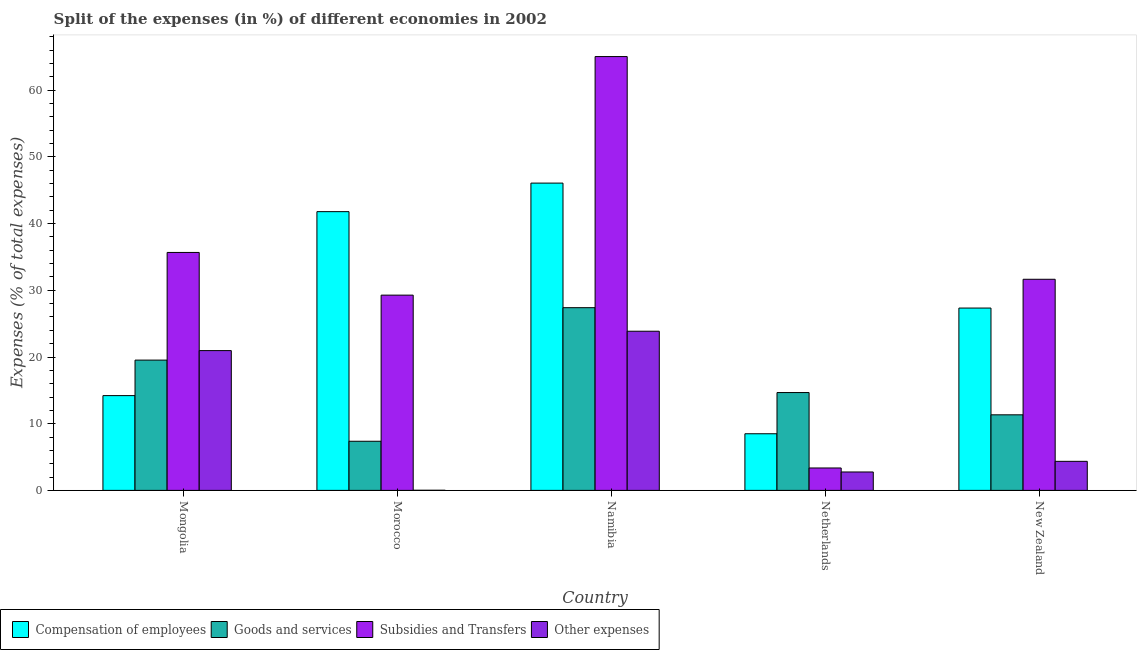How many different coloured bars are there?
Provide a succinct answer. 4. Are the number of bars per tick equal to the number of legend labels?
Keep it short and to the point. Yes. How many bars are there on the 4th tick from the right?
Provide a short and direct response. 4. What is the label of the 3rd group of bars from the left?
Provide a succinct answer. Namibia. What is the percentage of amount spent on other expenses in New Zealand?
Give a very brief answer. 4.36. Across all countries, what is the maximum percentage of amount spent on subsidies?
Offer a very short reply. 65.05. Across all countries, what is the minimum percentage of amount spent on goods and services?
Offer a terse response. 7.37. In which country was the percentage of amount spent on compensation of employees maximum?
Give a very brief answer. Namibia. In which country was the percentage of amount spent on goods and services minimum?
Your response must be concise. Morocco. What is the total percentage of amount spent on subsidies in the graph?
Your response must be concise. 165.03. What is the difference between the percentage of amount spent on subsidies in Namibia and that in Netherlands?
Your answer should be compact. 61.69. What is the difference between the percentage of amount spent on compensation of employees in Netherlands and the percentage of amount spent on subsidies in Mongolia?
Keep it short and to the point. -27.19. What is the average percentage of amount spent on other expenses per country?
Keep it short and to the point. 10.39. What is the difference between the percentage of amount spent on other expenses and percentage of amount spent on subsidies in New Zealand?
Your response must be concise. -27.3. In how many countries, is the percentage of amount spent on subsidies greater than 34 %?
Make the answer very short. 2. What is the ratio of the percentage of amount spent on subsidies in Mongolia to that in Netherlands?
Give a very brief answer. 10.62. Is the percentage of amount spent on goods and services in Mongolia less than that in Namibia?
Your response must be concise. Yes. Is the difference between the percentage of amount spent on subsidies in Mongolia and Netherlands greater than the difference between the percentage of amount spent on compensation of employees in Mongolia and Netherlands?
Keep it short and to the point. Yes. What is the difference between the highest and the second highest percentage of amount spent on other expenses?
Your response must be concise. 2.9. What is the difference between the highest and the lowest percentage of amount spent on subsidies?
Provide a short and direct response. 61.69. Is the sum of the percentage of amount spent on goods and services in Netherlands and New Zealand greater than the maximum percentage of amount spent on other expenses across all countries?
Your response must be concise. Yes. Is it the case that in every country, the sum of the percentage of amount spent on subsidies and percentage of amount spent on other expenses is greater than the sum of percentage of amount spent on goods and services and percentage of amount spent on compensation of employees?
Give a very brief answer. No. What does the 1st bar from the left in Namibia represents?
Your answer should be compact. Compensation of employees. What does the 3rd bar from the right in Mongolia represents?
Ensure brevity in your answer.  Goods and services. How many bars are there?
Offer a very short reply. 20. How many countries are there in the graph?
Offer a very short reply. 5. Are the values on the major ticks of Y-axis written in scientific E-notation?
Offer a terse response. No. Does the graph contain any zero values?
Provide a short and direct response. No. Does the graph contain grids?
Provide a succinct answer. No. Where does the legend appear in the graph?
Your answer should be very brief. Bottom left. How many legend labels are there?
Ensure brevity in your answer.  4. What is the title of the graph?
Offer a very short reply. Split of the expenses (in %) of different economies in 2002. What is the label or title of the Y-axis?
Provide a succinct answer. Expenses (% of total expenses). What is the Expenses (% of total expenses) in Compensation of employees in Mongolia?
Your response must be concise. 14.21. What is the Expenses (% of total expenses) of Goods and services in Mongolia?
Your answer should be very brief. 19.54. What is the Expenses (% of total expenses) in Subsidies and Transfers in Mongolia?
Offer a terse response. 35.68. What is the Expenses (% of total expenses) of Other expenses in Mongolia?
Give a very brief answer. 20.96. What is the Expenses (% of total expenses) in Compensation of employees in Morocco?
Ensure brevity in your answer.  41.8. What is the Expenses (% of total expenses) in Goods and services in Morocco?
Ensure brevity in your answer.  7.37. What is the Expenses (% of total expenses) in Subsidies and Transfers in Morocco?
Keep it short and to the point. 29.28. What is the Expenses (% of total expenses) of Other expenses in Morocco?
Give a very brief answer. 0.02. What is the Expenses (% of total expenses) in Compensation of employees in Namibia?
Your answer should be compact. 46.08. What is the Expenses (% of total expenses) of Goods and services in Namibia?
Provide a short and direct response. 27.4. What is the Expenses (% of total expenses) in Subsidies and Transfers in Namibia?
Your answer should be very brief. 65.05. What is the Expenses (% of total expenses) of Other expenses in Namibia?
Your response must be concise. 23.87. What is the Expenses (% of total expenses) of Compensation of employees in Netherlands?
Ensure brevity in your answer.  8.49. What is the Expenses (% of total expenses) of Goods and services in Netherlands?
Ensure brevity in your answer.  14.67. What is the Expenses (% of total expenses) in Subsidies and Transfers in Netherlands?
Keep it short and to the point. 3.36. What is the Expenses (% of total expenses) in Other expenses in Netherlands?
Provide a short and direct response. 2.76. What is the Expenses (% of total expenses) in Compensation of employees in New Zealand?
Your answer should be compact. 27.34. What is the Expenses (% of total expenses) in Goods and services in New Zealand?
Make the answer very short. 11.33. What is the Expenses (% of total expenses) in Subsidies and Transfers in New Zealand?
Your answer should be compact. 31.66. What is the Expenses (% of total expenses) in Other expenses in New Zealand?
Keep it short and to the point. 4.36. Across all countries, what is the maximum Expenses (% of total expenses) in Compensation of employees?
Ensure brevity in your answer.  46.08. Across all countries, what is the maximum Expenses (% of total expenses) in Goods and services?
Provide a short and direct response. 27.4. Across all countries, what is the maximum Expenses (% of total expenses) in Subsidies and Transfers?
Provide a short and direct response. 65.05. Across all countries, what is the maximum Expenses (% of total expenses) of Other expenses?
Offer a very short reply. 23.87. Across all countries, what is the minimum Expenses (% of total expenses) in Compensation of employees?
Offer a very short reply. 8.49. Across all countries, what is the minimum Expenses (% of total expenses) of Goods and services?
Keep it short and to the point. 7.37. Across all countries, what is the minimum Expenses (% of total expenses) of Subsidies and Transfers?
Your answer should be compact. 3.36. Across all countries, what is the minimum Expenses (% of total expenses) of Other expenses?
Your answer should be compact. 0.02. What is the total Expenses (% of total expenses) in Compensation of employees in the graph?
Your answer should be compact. 137.92. What is the total Expenses (% of total expenses) of Goods and services in the graph?
Ensure brevity in your answer.  80.3. What is the total Expenses (% of total expenses) of Subsidies and Transfers in the graph?
Offer a terse response. 165.03. What is the total Expenses (% of total expenses) of Other expenses in the graph?
Your answer should be compact. 51.96. What is the difference between the Expenses (% of total expenses) of Compensation of employees in Mongolia and that in Morocco?
Provide a succinct answer. -27.59. What is the difference between the Expenses (% of total expenses) in Goods and services in Mongolia and that in Morocco?
Your response must be concise. 12.17. What is the difference between the Expenses (% of total expenses) of Subsidies and Transfers in Mongolia and that in Morocco?
Make the answer very short. 6.4. What is the difference between the Expenses (% of total expenses) of Other expenses in Mongolia and that in Morocco?
Keep it short and to the point. 20.95. What is the difference between the Expenses (% of total expenses) in Compensation of employees in Mongolia and that in Namibia?
Give a very brief answer. -31.86. What is the difference between the Expenses (% of total expenses) in Goods and services in Mongolia and that in Namibia?
Offer a very short reply. -7.86. What is the difference between the Expenses (% of total expenses) in Subsidies and Transfers in Mongolia and that in Namibia?
Offer a terse response. -29.37. What is the difference between the Expenses (% of total expenses) of Other expenses in Mongolia and that in Namibia?
Your answer should be compact. -2.9. What is the difference between the Expenses (% of total expenses) in Compensation of employees in Mongolia and that in Netherlands?
Your answer should be very brief. 5.72. What is the difference between the Expenses (% of total expenses) in Goods and services in Mongolia and that in Netherlands?
Ensure brevity in your answer.  4.87. What is the difference between the Expenses (% of total expenses) in Subsidies and Transfers in Mongolia and that in Netherlands?
Offer a terse response. 32.32. What is the difference between the Expenses (% of total expenses) in Other expenses in Mongolia and that in Netherlands?
Offer a very short reply. 18.2. What is the difference between the Expenses (% of total expenses) of Compensation of employees in Mongolia and that in New Zealand?
Provide a short and direct response. -13.13. What is the difference between the Expenses (% of total expenses) in Goods and services in Mongolia and that in New Zealand?
Your answer should be very brief. 8.2. What is the difference between the Expenses (% of total expenses) of Subsidies and Transfers in Mongolia and that in New Zealand?
Provide a short and direct response. 4.02. What is the difference between the Expenses (% of total expenses) of Other expenses in Mongolia and that in New Zealand?
Provide a short and direct response. 16.6. What is the difference between the Expenses (% of total expenses) in Compensation of employees in Morocco and that in Namibia?
Provide a short and direct response. -4.28. What is the difference between the Expenses (% of total expenses) of Goods and services in Morocco and that in Namibia?
Keep it short and to the point. -20.03. What is the difference between the Expenses (% of total expenses) of Subsidies and Transfers in Morocco and that in Namibia?
Your answer should be compact. -35.77. What is the difference between the Expenses (% of total expenses) of Other expenses in Morocco and that in Namibia?
Your answer should be compact. -23.85. What is the difference between the Expenses (% of total expenses) in Compensation of employees in Morocco and that in Netherlands?
Your response must be concise. 33.3. What is the difference between the Expenses (% of total expenses) of Goods and services in Morocco and that in Netherlands?
Ensure brevity in your answer.  -7.3. What is the difference between the Expenses (% of total expenses) of Subsidies and Transfers in Morocco and that in Netherlands?
Make the answer very short. 25.92. What is the difference between the Expenses (% of total expenses) in Other expenses in Morocco and that in Netherlands?
Your answer should be very brief. -2.74. What is the difference between the Expenses (% of total expenses) of Compensation of employees in Morocco and that in New Zealand?
Your answer should be very brief. 14.46. What is the difference between the Expenses (% of total expenses) of Goods and services in Morocco and that in New Zealand?
Your response must be concise. -3.96. What is the difference between the Expenses (% of total expenses) of Subsidies and Transfers in Morocco and that in New Zealand?
Offer a terse response. -2.38. What is the difference between the Expenses (% of total expenses) in Other expenses in Morocco and that in New Zealand?
Make the answer very short. -4.34. What is the difference between the Expenses (% of total expenses) of Compensation of employees in Namibia and that in Netherlands?
Offer a very short reply. 37.58. What is the difference between the Expenses (% of total expenses) in Goods and services in Namibia and that in Netherlands?
Give a very brief answer. 12.73. What is the difference between the Expenses (% of total expenses) of Subsidies and Transfers in Namibia and that in Netherlands?
Provide a short and direct response. 61.69. What is the difference between the Expenses (% of total expenses) in Other expenses in Namibia and that in Netherlands?
Offer a terse response. 21.1. What is the difference between the Expenses (% of total expenses) of Compensation of employees in Namibia and that in New Zealand?
Your answer should be very brief. 18.74. What is the difference between the Expenses (% of total expenses) of Goods and services in Namibia and that in New Zealand?
Keep it short and to the point. 16.07. What is the difference between the Expenses (% of total expenses) in Subsidies and Transfers in Namibia and that in New Zealand?
Ensure brevity in your answer.  33.39. What is the difference between the Expenses (% of total expenses) in Other expenses in Namibia and that in New Zealand?
Make the answer very short. 19.51. What is the difference between the Expenses (% of total expenses) in Compensation of employees in Netherlands and that in New Zealand?
Offer a very short reply. -18.85. What is the difference between the Expenses (% of total expenses) of Goods and services in Netherlands and that in New Zealand?
Provide a succinct answer. 3.34. What is the difference between the Expenses (% of total expenses) in Subsidies and Transfers in Netherlands and that in New Zealand?
Your answer should be very brief. -28.3. What is the difference between the Expenses (% of total expenses) of Other expenses in Netherlands and that in New Zealand?
Keep it short and to the point. -1.6. What is the difference between the Expenses (% of total expenses) in Compensation of employees in Mongolia and the Expenses (% of total expenses) in Goods and services in Morocco?
Make the answer very short. 6.84. What is the difference between the Expenses (% of total expenses) of Compensation of employees in Mongolia and the Expenses (% of total expenses) of Subsidies and Transfers in Morocco?
Make the answer very short. -15.07. What is the difference between the Expenses (% of total expenses) of Compensation of employees in Mongolia and the Expenses (% of total expenses) of Other expenses in Morocco?
Keep it short and to the point. 14.2. What is the difference between the Expenses (% of total expenses) of Goods and services in Mongolia and the Expenses (% of total expenses) of Subsidies and Transfers in Morocco?
Keep it short and to the point. -9.74. What is the difference between the Expenses (% of total expenses) in Goods and services in Mongolia and the Expenses (% of total expenses) in Other expenses in Morocco?
Keep it short and to the point. 19.52. What is the difference between the Expenses (% of total expenses) in Subsidies and Transfers in Mongolia and the Expenses (% of total expenses) in Other expenses in Morocco?
Make the answer very short. 35.66. What is the difference between the Expenses (% of total expenses) in Compensation of employees in Mongolia and the Expenses (% of total expenses) in Goods and services in Namibia?
Keep it short and to the point. -13.19. What is the difference between the Expenses (% of total expenses) in Compensation of employees in Mongolia and the Expenses (% of total expenses) in Subsidies and Transfers in Namibia?
Offer a very short reply. -50.84. What is the difference between the Expenses (% of total expenses) of Compensation of employees in Mongolia and the Expenses (% of total expenses) of Other expenses in Namibia?
Provide a succinct answer. -9.65. What is the difference between the Expenses (% of total expenses) in Goods and services in Mongolia and the Expenses (% of total expenses) in Subsidies and Transfers in Namibia?
Provide a succinct answer. -45.51. What is the difference between the Expenses (% of total expenses) in Goods and services in Mongolia and the Expenses (% of total expenses) in Other expenses in Namibia?
Offer a terse response. -4.33. What is the difference between the Expenses (% of total expenses) in Subsidies and Transfers in Mongolia and the Expenses (% of total expenses) in Other expenses in Namibia?
Offer a terse response. 11.81. What is the difference between the Expenses (% of total expenses) of Compensation of employees in Mongolia and the Expenses (% of total expenses) of Goods and services in Netherlands?
Provide a succinct answer. -0.46. What is the difference between the Expenses (% of total expenses) of Compensation of employees in Mongolia and the Expenses (% of total expenses) of Subsidies and Transfers in Netherlands?
Make the answer very short. 10.85. What is the difference between the Expenses (% of total expenses) of Compensation of employees in Mongolia and the Expenses (% of total expenses) of Other expenses in Netherlands?
Make the answer very short. 11.45. What is the difference between the Expenses (% of total expenses) of Goods and services in Mongolia and the Expenses (% of total expenses) of Subsidies and Transfers in Netherlands?
Your answer should be very brief. 16.18. What is the difference between the Expenses (% of total expenses) in Goods and services in Mongolia and the Expenses (% of total expenses) in Other expenses in Netherlands?
Provide a short and direct response. 16.78. What is the difference between the Expenses (% of total expenses) of Subsidies and Transfers in Mongolia and the Expenses (% of total expenses) of Other expenses in Netherlands?
Make the answer very short. 32.92. What is the difference between the Expenses (% of total expenses) of Compensation of employees in Mongolia and the Expenses (% of total expenses) of Goods and services in New Zealand?
Offer a terse response. 2.88. What is the difference between the Expenses (% of total expenses) of Compensation of employees in Mongolia and the Expenses (% of total expenses) of Subsidies and Transfers in New Zealand?
Make the answer very short. -17.45. What is the difference between the Expenses (% of total expenses) of Compensation of employees in Mongolia and the Expenses (% of total expenses) of Other expenses in New Zealand?
Ensure brevity in your answer.  9.86. What is the difference between the Expenses (% of total expenses) of Goods and services in Mongolia and the Expenses (% of total expenses) of Subsidies and Transfers in New Zealand?
Your answer should be compact. -12.12. What is the difference between the Expenses (% of total expenses) of Goods and services in Mongolia and the Expenses (% of total expenses) of Other expenses in New Zealand?
Offer a terse response. 15.18. What is the difference between the Expenses (% of total expenses) of Subsidies and Transfers in Mongolia and the Expenses (% of total expenses) of Other expenses in New Zealand?
Give a very brief answer. 31.32. What is the difference between the Expenses (% of total expenses) of Compensation of employees in Morocco and the Expenses (% of total expenses) of Goods and services in Namibia?
Your answer should be very brief. 14.4. What is the difference between the Expenses (% of total expenses) of Compensation of employees in Morocco and the Expenses (% of total expenses) of Subsidies and Transfers in Namibia?
Make the answer very short. -23.25. What is the difference between the Expenses (% of total expenses) of Compensation of employees in Morocco and the Expenses (% of total expenses) of Other expenses in Namibia?
Keep it short and to the point. 17.93. What is the difference between the Expenses (% of total expenses) in Goods and services in Morocco and the Expenses (% of total expenses) in Subsidies and Transfers in Namibia?
Provide a short and direct response. -57.68. What is the difference between the Expenses (% of total expenses) of Goods and services in Morocco and the Expenses (% of total expenses) of Other expenses in Namibia?
Offer a terse response. -16.5. What is the difference between the Expenses (% of total expenses) in Subsidies and Transfers in Morocco and the Expenses (% of total expenses) in Other expenses in Namibia?
Your answer should be compact. 5.41. What is the difference between the Expenses (% of total expenses) of Compensation of employees in Morocco and the Expenses (% of total expenses) of Goods and services in Netherlands?
Your answer should be very brief. 27.13. What is the difference between the Expenses (% of total expenses) in Compensation of employees in Morocco and the Expenses (% of total expenses) in Subsidies and Transfers in Netherlands?
Your answer should be very brief. 38.44. What is the difference between the Expenses (% of total expenses) in Compensation of employees in Morocco and the Expenses (% of total expenses) in Other expenses in Netherlands?
Offer a very short reply. 39.04. What is the difference between the Expenses (% of total expenses) of Goods and services in Morocco and the Expenses (% of total expenses) of Subsidies and Transfers in Netherlands?
Ensure brevity in your answer.  4.01. What is the difference between the Expenses (% of total expenses) in Goods and services in Morocco and the Expenses (% of total expenses) in Other expenses in Netherlands?
Make the answer very short. 4.61. What is the difference between the Expenses (% of total expenses) of Subsidies and Transfers in Morocco and the Expenses (% of total expenses) of Other expenses in Netherlands?
Your answer should be very brief. 26.52. What is the difference between the Expenses (% of total expenses) of Compensation of employees in Morocco and the Expenses (% of total expenses) of Goods and services in New Zealand?
Your answer should be compact. 30.47. What is the difference between the Expenses (% of total expenses) in Compensation of employees in Morocco and the Expenses (% of total expenses) in Subsidies and Transfers in New Zealand?
Offer a very short reply. 10.14. What is the difference between the Expenses (% of total expenses) of Compensation of employees in Morocco and the Expenses (% of total expenses) of Other expenses in New Zealand?
Ensure brevity in your answer.  37.44. What is the difference between the Expenses (% of total expenses) in Goods and services in Morocco and the Expenses (% of total expenses) in Subsidies and Transfers in New Zealand?
Your answer should be very brief. -24.29. What is the difference between the Expenses (% of total expenses) in Goods and services in Morocco and the Expenses (% of total expenses) in Other expenses in New Zealand?
Give a very brief answer. 3.01. What is the difference between the Expenses (% of total expenses) of Subsidies and Transfers in Morocco and the Expenses (% of total expenses) of Other expenses in New Zealand?
Keep it short and to the point. 24.92. What is the difference between the Expenses (% of total expenses) of Compensation of employees in Namibia and the Expenses (% of total expenses) of Goods and services in Netherlands?
Make the answer very short. 31.41. What is the difference between the Expenses (% of total expenses) in Compensation of employees in Namibia and the Expenses (% of total expenses) in Subsidies and Transfers in Netherlands?
Keep it short and to the point. 42.72. What is the difference between the Expenses (% of total expenses) of Compensation of employees in Namibia and the Expenses (% of total expenses) of Other expenses in Netherlands?
Ensure brevity in your answer.  43.32. What is the difference between the Expenses (% of total expenses) in Goods and services in Namibia and the Expenses (% of total expenses) in Subsidies and Transfers in Netherlands?
Offer a very short reply. 24.04. What is the difference between the Expenses (% of total expenses) in Goods and services in Namibia and the Expenses (% of total expenses) in Other expenses in Netherlands?
Keep it short and to the point. 24.64. What is the difference between the Expenses (% of total expenses) of Subsidies and Transfers in Namibia and the Expenses (% of total expenses) of Other expenses in Netherlands?
Ensure brevity in your answer.  62.29. What is the difference between the Expenses (% of total expenses) in Compensation of employees in Namibia and the Expenses (% of total expenses) in Goods and services in New Zealand?
Your answer should be very brief. 34.74. What is the difference between the Expenses (% of total expenses) in Compensation of employees in Namibia and the Expenses (% of total expenses) in Subsidies and Transfers in New Zealand?
Keep it short and to the point. 14.42. What is the difference between the Expenses (% of total expenses) of Compensation of employees in Namibia and the Expenses (% of total expenses) of Other expenses in New Zealand?
Your answer should be compact. 41.72. What is the difference between the Expenses (% of total expenses) in Goods and services in Namibia and the Expenses (% of total expenses) in Subsidies and Transfers in New Zealand?
Your answer should be very brief. -4.26. What is the difference between the Expenses (% of total expenses) in Goods and services in Namibia and the Expenses (% of total expenses) in Other expenses in New Zealand?
Give a very brief answer. 23.04. What is the difference between the Expenses (% of total expenses) in Subsidies and Transfers in Namibia and the Expenses (% of total expenses) in Other expenses in New Zealand?
Provide a succinct answer. 60.69. What is the difference between the Expenses (% of total expenses) of Compensation of employees in Netherlands and the Expenses (% of total expenses) of Goods and services in New Zealand?
Give a very brief answer. -2.84. What is the difference between the Expenses (% of total expenses) of Compensation of employees in Netherlands and the Expenses (% of total expenses) of Subsidies and Transfers in New Zealand?
Make the answer very short. -23.16. What is the difference between the Expenses (% of total expenses) in Compensation of employees in Netherlands and the Expenses (% of total expenses) in Other expenses in New Zealand?
Make the answer very short. 4.14. What is the difference between the Expenses (% of total expenses) of Goods and services in Netherlands and the Expenses (% of total expenses) of Subsidies and Transfers in New Zealand?
Your answer should be very brief. -16.99. What is the difference between the Expenses (% of total expenses) in Goods and services in Netherlands and the Expenses (% of total expenses) in Other expenses in New Zealand?
Your answer should be very brief. 10.31. What is the difference between the Expenses (% of total expenses) in Subsidies and Transfers in Netherlands and the Expenses (% of total expenses) in Other expenses in New Zealand?
Offer a terse response. -1. What is the average Expenses (% of total expenses) in Compensation of employees per country?
Offer a very short reply. 27.58. What is the average Expenses (% of total expenses) of Goods and services per country?
Your answer should be very brief. 16.06. What is the average Expenses (% of total expenses) of Subsidies and Transfers per country?
Give a very brief answer. 33.01. What is the average Expenses (% of total expenses) of Other expenses per country?
Your response must be concise. 10.39. What is the difference between the Expenses (% of total expenses) of Compensation of employees and Expenses (% of total expenses) of Goods and services in Mongolia?
Offer a very short reply. -5.32. What is the difference between the Expenses (% of total expenses) in Compensation of employees and Expenses (% of total expenses) in Subsidies and Transfers in Mongolia?
Your answer should be very brief. -21.47. What is the difference between the Expenses (% of total expenses) of Compensation of employees and Expenses (% of total expenses) of Other expenses in Mongolia?
Your answer should be compact. -6.75. What is the difference between the Expenses (% of total expenses) of Goods and services and Expenses (% of total expenses) of Subsidies and Transfers in Mongolia?
Your answer should be very brief. -16.14. What is the difference between the Expenses (% of total expenses) of Goods and services and Expenses (% of total expenses) of Other expenses in Mongolia?
Provide a short and direct response. -1.42. What is the difference between the Expenses (% of total expenses) of Subsidies and Transfers and Expenses (% of total expenses) of Other expenses in Mongolia?
Provide a succinct answer. 14.72. What is the difference between the Expenses (% of total expenses) in Compensation of employees and Expenses (% of total expenses) in Goods and services in Morocco?
Provide a succinct answer. 34.43. What is the difference between the Expenses (% of total expenses) in Compensation of employees and Expenses (% of total expenses) in Subsidies and Transfers in Morocco?
Keep it short and to the point. 12.52. What is the difference between the Expenses (% of total expenses) of Compensation of employees and Expenses (% of total expenses) of Other expenses in Morocco?
Your answer should be very brief. 41.78. What is the difference between the Expenses (% of total expenses) of Goods and services and Expenses (% of total expenses) of Subsidies and Transfers in Morocco?
Keep it short and to the point. -21.91. What is the difference between the Expenses (% of total expenses) of Goods and services and Expenses (% of total expenses) of Other expenses in Morocco?
Your answer should be compact. 7.35. What is the difference between the Expenses (% of total expenses) of Subsidies and Transfers and Expenses (% of total expenses) of Other expenses in Morocco?
Offer a terse response. 29.26. What is the difference between the Expenses (% of total expenses) of Compensation of employees and Expenses (% of total expenses) of Goods and services in Namibia?
Offer a terse response. 18.68. What is the difference between the Expenses (% of total expenses) in Compensation of employees and Expenses (% of total expenses) in Subsidies and Transfers in Namibia?
Offer a very short reply. -18.97. What is the difference between the Expenses (% of total expenses) of Compensation of employees and Expenses (% of total expenses) of Other expenses in Namibia?
Make the answer very short. 22.21. What is the difference between the Expenses (% of total expenses) in Goods and services and Expenses (% of total expenses) in Subsidies and Transfers in Namibia?
Give a very brief answer. -37.65. What is the difference between the Expenses (% of total expenses) in Goods and services and Expenses (% of total expenses) in Other expenses in Namibia?
Your answer should be very brief. 3.53. What is the difference between the Expenses (% of total expenses) in Subsidies and Transfers and Expenses (% of total expenses) in Other expenses in Namibia?
Offer a very short reply. 41.19. What is the difference between the Expenses (% of total expenses) in Compensation of employees and Expenses (% of total expenses) in Goods and services in Netherlands?
Ensure brevity in your answer.  -6.18. What is the difference between the Expenses (% of total expenses) of Compensation of employees and Expenses (% of total expenses) of Subsidies and Transfers in Netherlands?
Your answer should be very brief. 5.13. What is the difference between the Expenses (% of total expenses) in Compensation of employees and Expenses (% of total expenses) in Other expenses in Netherlands?
Your answer should be compact. 5.73. What is the difference between the Expenses (% of total expenses) of Goods and services and Expenses (% of total expenses) of Subsidies and Transfers in Netherlands?
Your response must be concise. 11.31. What is the difference between the Expenses (% of total expenses) in Goods and services and Expenses (% of total expenses) in Other expenses in Netherlands?
Ensure brevity in your answer.  11.91. What is the difference between the Expenses (% of total expenses) in Subsidies and Transfers and Expenses (% of total expenses) in Other expenses in Netherlands?
Give a very brief answer. 0.6. What is the difference between the Expenses (% of total expenses) in Compensation of employees and Expenses (% of total expenses) in Goods and services in New Zealand?
Make the answer very short. 16.01. What is the difference between the Expenses (% of total expenses) in Compensation of employees and Expenses (% of total expenses) in Subsidies and Transfers in New Zealand?
Offer a very short reply. -4.32. What is the difference between the Expenses (% of total expenses) of Compensation of employees and Expenses (% of total expenses) of Other expenses in New Zealand?
Your answer should be very brief. 22.98. What is the difference between the Expenses (% of total expenses) in Goods and services and Expenses (% of total expenses) in Subsidies and Transfers in New Zealand?
Ensure brevity in your answer.  -20.32. What is the difference between the Expenses (% of total expenses) in Goods and services and Expenses (% of total expenses) in Other expenses in New Zealand?
Your answer should be very brief. 6.98. What is the difference between the Expenses (% of total expenses) of Subsidies and Transfers and Expenses (% of total expenses) of Other expenses in New Zealand?
Your answer should be very brief. 27.3. What is the ratio of the Expenses (% of total expenses) in Compensation of employees in Mongolia to that in Morocco?
Your response must be concise. 0.34. What is the ratio of the Expenses (% of total expenses) of Goods and services in Mongolia to that in Morocco?
Your answer should be compact. 2.65. What is the ratio of the Expenses (% of total expenses) of Subsidies and Transfers in Mongolia to that in Morocco?
Your response must be concise. 1.22. What is the ratio of the Expenses (% of total expenses) of Other expenses in Mongolia to that in Morocco?
Provide a succinct answer. 1265.03. What is the ratio of the Expenses (% of total expenses) in Compensation of employees in Mongolia to that in Namibia?
Your answer should be very brief. 0.31. What is the ratio of the Expenses (% of total expenses) of Goods and services in Mongolia to that in Namibia?
Offer a very short reply. 0.71. What is the ratio of the Expenses (% of total expenses) of Subsidies and Transfers in Mongolia to that in Namibia?
Ensure brevity in your answer.  0.55. What is the ratio of the Expenses (% of total expenses) in Other expenses in Mongolia to that in Namibia?
Your response must be concise. 0.88. What is the ratio of the Expenses (% of total expenses) of Compensation of employees in Mongolia to that in Netherlands?
Ensure brevity in your answer.  1.67. What is the ratio of the Expenses (% of total expenses) of Goods and services in Mongolia to that in Netherlands?
Provide a succinct answer. 1.33. What is the ratio of the Expenses (% of total expenses) in Subsidies and Transfers in Mongolia to that in Netherlands?
Offer a terse response. 10.62. What is the ratio of the Expenses (% of total expenses) of Other expenses in Mongolia to that in Netherlands?
Provide a succinct answer. 7.59. What is the ratio of the Expenses (% of total expenses) in Compensation of employees in Mongolia to that in New Zealand?
Give a very brief answer. 0.52. What is the ratio of the Expenses (% of total expenses) of Goods and services in Mongolia to that in New Zealand?
Your answer should be compact. 1.72. What is the ratio of the Expenses (% of total expenses) of Subsidies and Transfers in Mongolia to that in New Zealand?
Your answer should be compact. 1.13. What is the ratio of the Expenses (% of total expenses) of Other expenses in Mongolia to that in New Zealand?
Your answer should be very brief. 4.81. What is the ratio of the Expenses (% of total expenses) in Compensation of employees in Morocco to that in Namibia?
Give a very brief answer. 0.91. What is the ratio of the Expenses (% of total expenses) in Goods and services in Morocco to that in Namibia?
Provide a short and direct response. 0.27. What is the ratio of the Expenses (% of total expenses) in Subsidies and Transfers in Morocco to that in Namibia?
Your response must be concise. 0.45. What is the ratio of the Expenses (% of total expenses) in Other expenses in Morocco to that in Namibia?
Give a very brief answer. 0. What is the ratio of the Expenses (% of total expenses) of Compensation of employees in Morocco to that in Netherlands?
Give a very brief answer. 4.92. What is the ratio of the Expenses (% of total expenses) in Goods and services in Morocco to that in Netherlands?
Provide a succinct answer. 0.5. What is the ratio of the Expenses (% of total expenses) in Subsidies and Transfers in Morocco to that in Netherlands?
Keep it short and to the point. 8.71. What is the ratio of the Expenses (% of total expenses) in Other expenses in Morocco to that in Netherlands?
Provide a succinct answer. 0.01. What is the ratio of the Expenses (% of total expenses) of Compensation of employees in Morocco to that in New Zealand?
Offer a very short reply. 1.53. What is the ratio of the Expenses (% of total expenses) of Goods and services in Morocco to that in New Zealand?
Provide a succinct answer. 0.65. What is the ratio of the Expenses (% of total expenses) in Subsidies and Transfers in Morocco to that in New Zealand?
Provide a succinct answer. 0.92. What is the ratio of the Expenses (% of total expenses) in Other expenses in Morocco to that in New Zealand?
Provide a succinct answer. 0. What is the ratio of the Expenses (% of total expenses) of Compensation of employees in Namibia to that in Netherlands?
Make the answer very short. 5.43. What is the ratio of the Expenses (% of total expenses) of Goods and services in Namibia to that in Netherlands?
Offer a very short reply. 1.87. What is the ratio of the Expenses (% of total expenses) in Subsidies and Transfers in Namibia to that in Netherlands?
Your response must be concise. 19.36. What is the ratio of the Expenses (% of total expenses) of Other expenses in Namibia to that in Netherlands?
Provide a succinct answer. 8.64. What is the ratio of the Expenses (% of total expenses) of Compensation of employees in Namibia to that in New Zealand?
Provide a succinct answer. 1.69. What is the ratio of the Expenses (% of total expenses) in Goods and services in Namibia to that in New Zealand?
Offer a very short reply. 2.42. What is the ratio of the Expenses (% of total expenses) of Subsidies and Transfers in Namibia to that in New Zealand?
Ensure brevity in your answer.  2.05. What is the ratio of the Expenses (% of total expenses) in Other expenses in Namibia to that in New Zealand?
Provide a succinct answer. 5.48. What is the ratio of the Expenses (% of total expenses) in Compensation of employees in Netherlands to that in New Zealand?
Give a very brief answer. 0.31. What is the ratio of the Expenses (% of total expenses) in Goods and services in Netherlands to that in New Zealand?
Your response must be concise. 1.29. What is the ratio of the Expenses (% of total expenses) in Subsidies and Transfers in Netherlands to that in New Zealand?
Your answer should be very brief. 0.11. What is the ratio of the Expenses (% of total expenses) of Other expenses in Netherlands to that in New Zealand?
Offer a terse response. 0.63. What is the difference between the highest and the second highest Expenses (% of total expenses) in Compensation of employees?
Your response must be concise. 4.28. What is the difference between the highest and the second highest Expenses (% of total expenses) in Goods and services?
Keep it short and to the point. 7.86. What is the difference between the highest and the second highest Expenses (% of total expenses) in Subsidies and Transfers?
Your answer should be very brief. 29.37. What is the difference between the highest and the second highest Expenses (% of total expenses) of Other expenses?
Ensure brevity in your answer.  2.9. What is the difference between the highest and the lowest Expenses (% of total expenses) of Compensation of employees?
Offer a very short reply. 37.58. What is the difference between the highest and the lowest Expenses (% of total expenses) of Goods and services?
Your answer should be compact. 20.03. What is the difference between the highest and the lowest Expenses (% of total expenses) of Subsidies and Transfers?
Your answer should be compact. 61.69. What is the difference between the highest and the lowest Expenses (% of total expenses) in Other expenses?
Give a very brief answer. 23.85. 